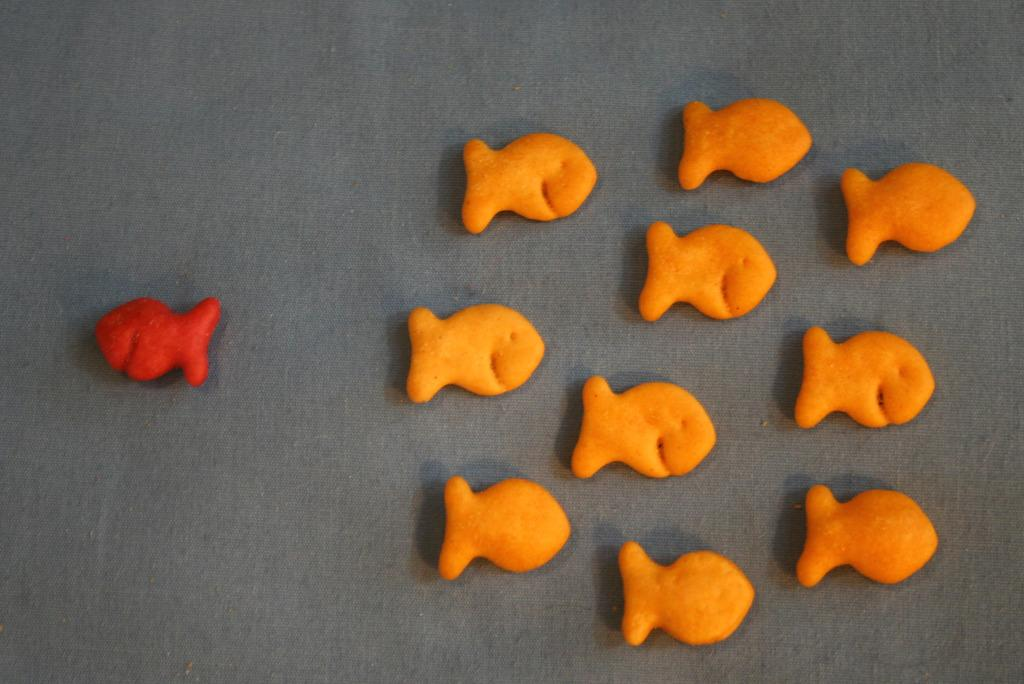What shapes are the objects in the image? The objects in the image are fish-shaped. What is the color of the surface on which the objects are placed? The objects are placed on a grey surface. What type of crime is being committed in the image involving the fish-shaped objects? There is no crime depicted in the image; it only shows fish-shaped objects on a grey surface. 